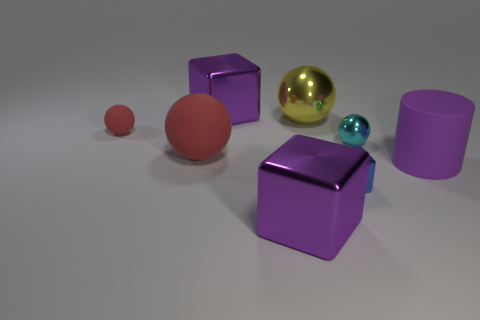Add 1 small shiny things. How many objects exist? 9 Subtract all cylinders. How many objects are left? 7 Subtract all big blue rubber blocks. Subtract all tiny red balls. How many objects are left? 7 Add 3 big purple shiny things. How many big purple shiny things are left? 5 Add 1 big yellow things. How many big yellow things exist? 2 Subtract 1 yellow spheres. How many objects are left? 7 